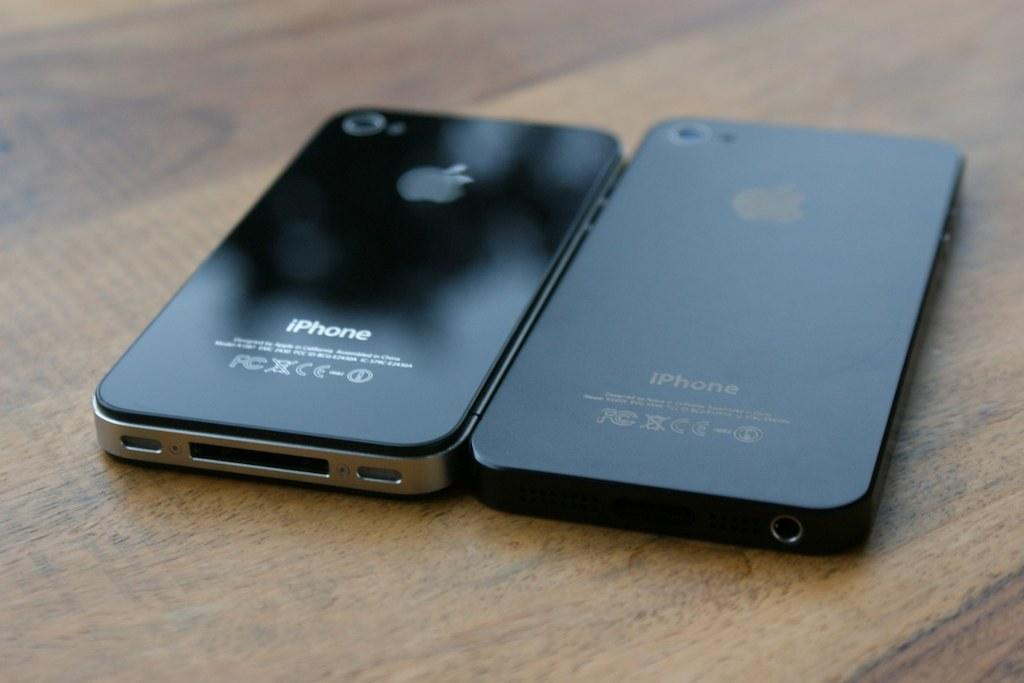<image>
Relay a brief, clear account of the picture shown. The backs of two different models of iPhones next to each other. 